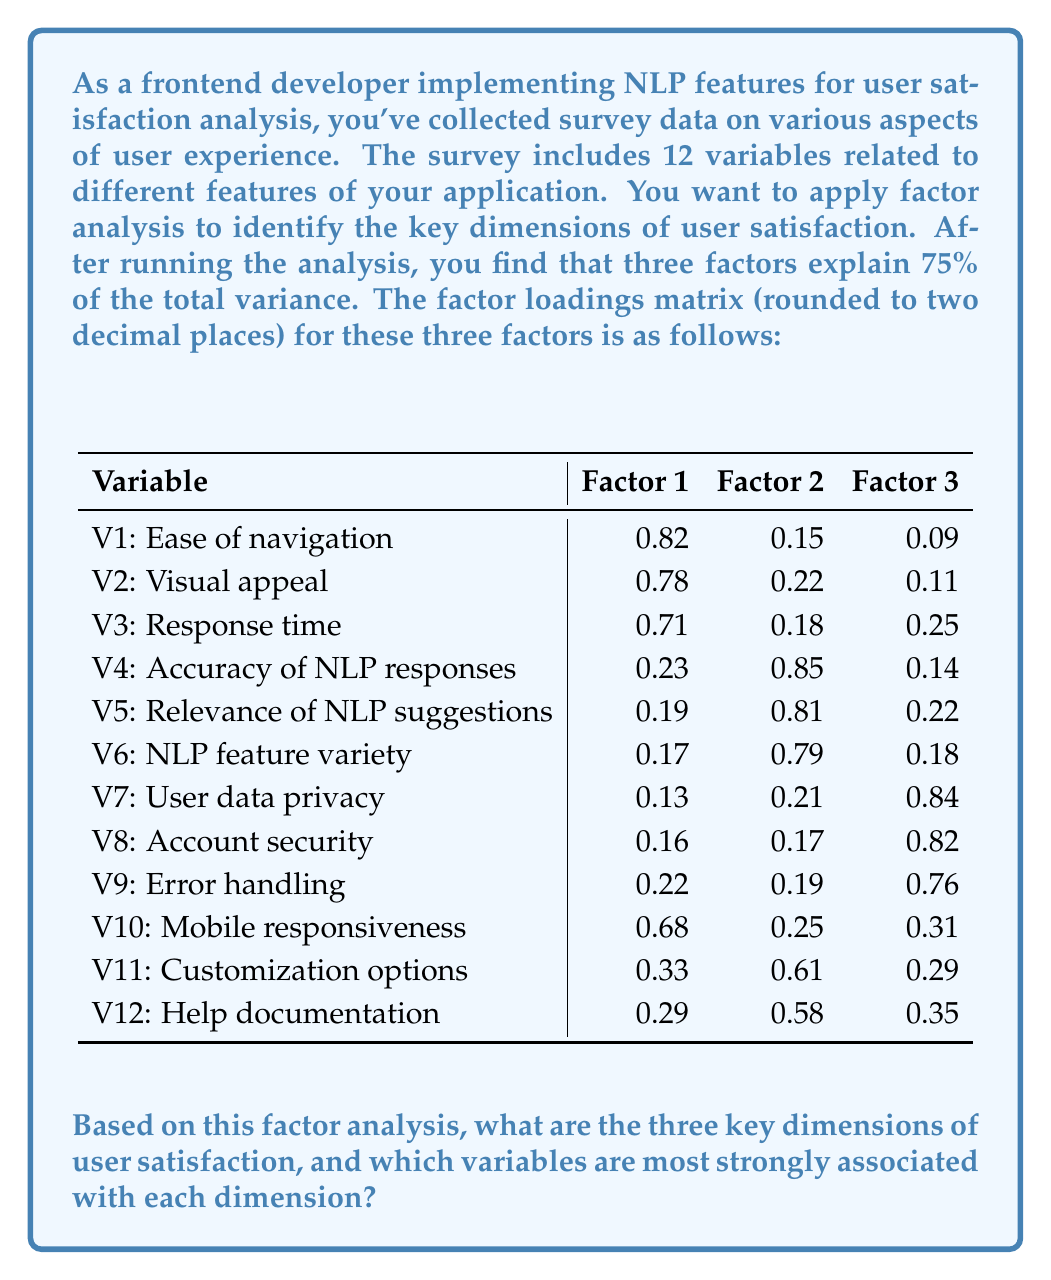Help me with this question. To identify the key dimensions of user satisfaction and their associated variables, we need to analyze the factor loadings matrix. We'll follow these steps:

1. Identify the highest factor loading for each variable.
2. Group variables by their highest factor loadings.
3. Interpret the meaning of each factor based on the grouped variables.

Let's analyze each factor:

Factor 1:
- Highest loadings: V1 (0.82), V2 (0.78), V3 (0.71), V10 (0.68)
- These variables relate to the user interface and performance aspects.
- We can interpret this factor as "User Interface and Performance"

Factor 2:
- Highest loadings: V4 (0.85), V5 (0.81), V6 (0.79), V11 (0.61), V12 (0.58)
- These variables are primarily related to NLP features and customization.
- We can interpret this factor as "NLP Functionality and Customization"

Factor 3:
- Highest loadings: V7 (0.84), V8 (0.82), V9 (0.76)
- These variables are associated with security, privacy, and reliability.
- We can interpret this factor as "Security and Reliability"

Now, let's summarize the key dimensions and their most strongly associated variables:

1. User Interface and Performance
   - V1: Ease of navigation (0.82)
   - V2: Visual appeal (0.78)
   - V3: Response time (0.71)
   - V10: Mobile responsiveness (0.68)

2. NLP Functionality and Customization
   - V4: Accuracy of NLP responses (0.85)
   - V5: Relevance of NLP suggestions (0.81)
   - V6: NLP feature variety (0.79)
   - V11: Customization options (0.61)
   - V12: Help documentation (0.58)

3. Security and Reliability
   - V7: User data privacy (0.84)
   - V8: Account security (0.82)
   - V9: Error handling (0.76)

These three factors explain 75% of the total variance, indicating that they capture the main dimensions of user satisfaction for this application.
Answer: The three key dimensions of user satisfaction are:
1. User Interface and Performance
2. NLP Functionality and Customization
3. Security and Reliability

The variables most strongly associated with each dimension are:
1. User Interface and Performance: Ease of navigation, Visual appeal, Response time, Mobile responsiveness
2. NLP Functionality and Customization: Accuracy of NLP responses, Relevance of NLP suggestions, NLP feature variety
3. Security and Reliability: User data privacy, Account security, Error handling 